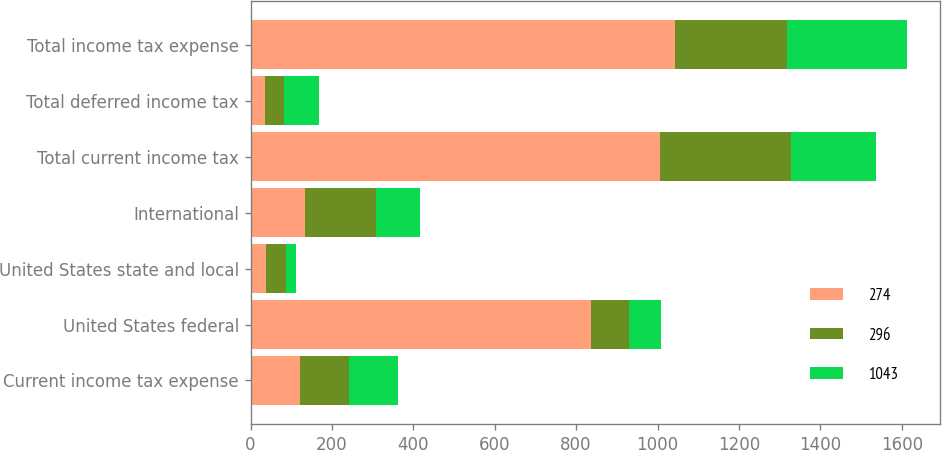Convert chart. <chart><loc_0><loc_0><loc_500><loc_500><stacked_bar_chart><ecel><fcel>Current income tax expense<fcel>United States federal<fcel>United States state and local<fcel>International<fcel>Total current income tax<fcel>Total deferred income tax<fcel>Total income tax expense<nl><fcel>274<fcel>120.5<fcel>836<fcel>38<fcel>133<fcel>1007<fcel>36<fcel>1043<nl><fcel>296<fcel>120.5<fcel>94<fcel>50<fcel>176<fcel>320<fcel>46<fcel>274<nl><fcel>1043<fcel>120.5<fcel>78<fcel>23<fcel>108<fcel>209<fcel>87<fcel>296<nl></chart> 